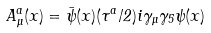Convert formula to latex. <formula><loc_0><loc_0><loc_500><loc_500>A _ { \mu } ^ { a } ( x ) = \bar { \psi } ( x ) ( \tau ^ { a } / 2 ) i \gamma _ { \mu } \gamma _ { 5 } \psi ( x )</formula> 